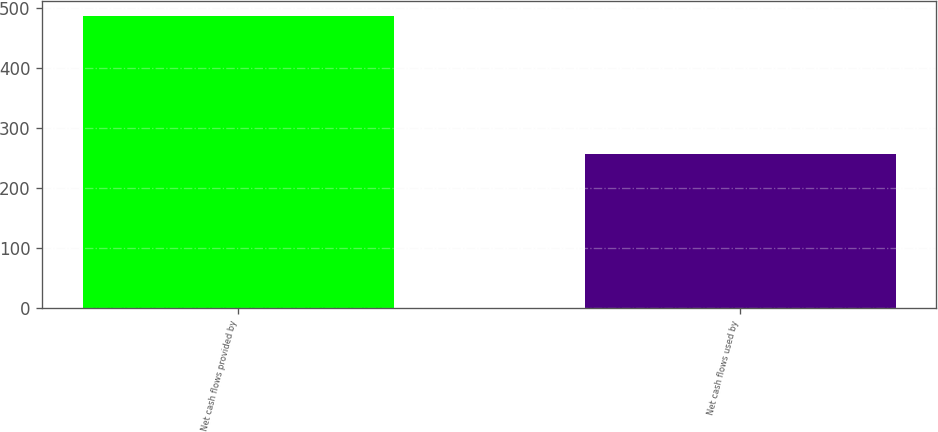Convert chart. <chart><loc_0><loc_0><loc_500><loc_500><bar_chart><fcel>Net cash flows provided by<fcel>Net cash flows used by<nl><fcel>487.8<fcel>255.8<nl></chart> 